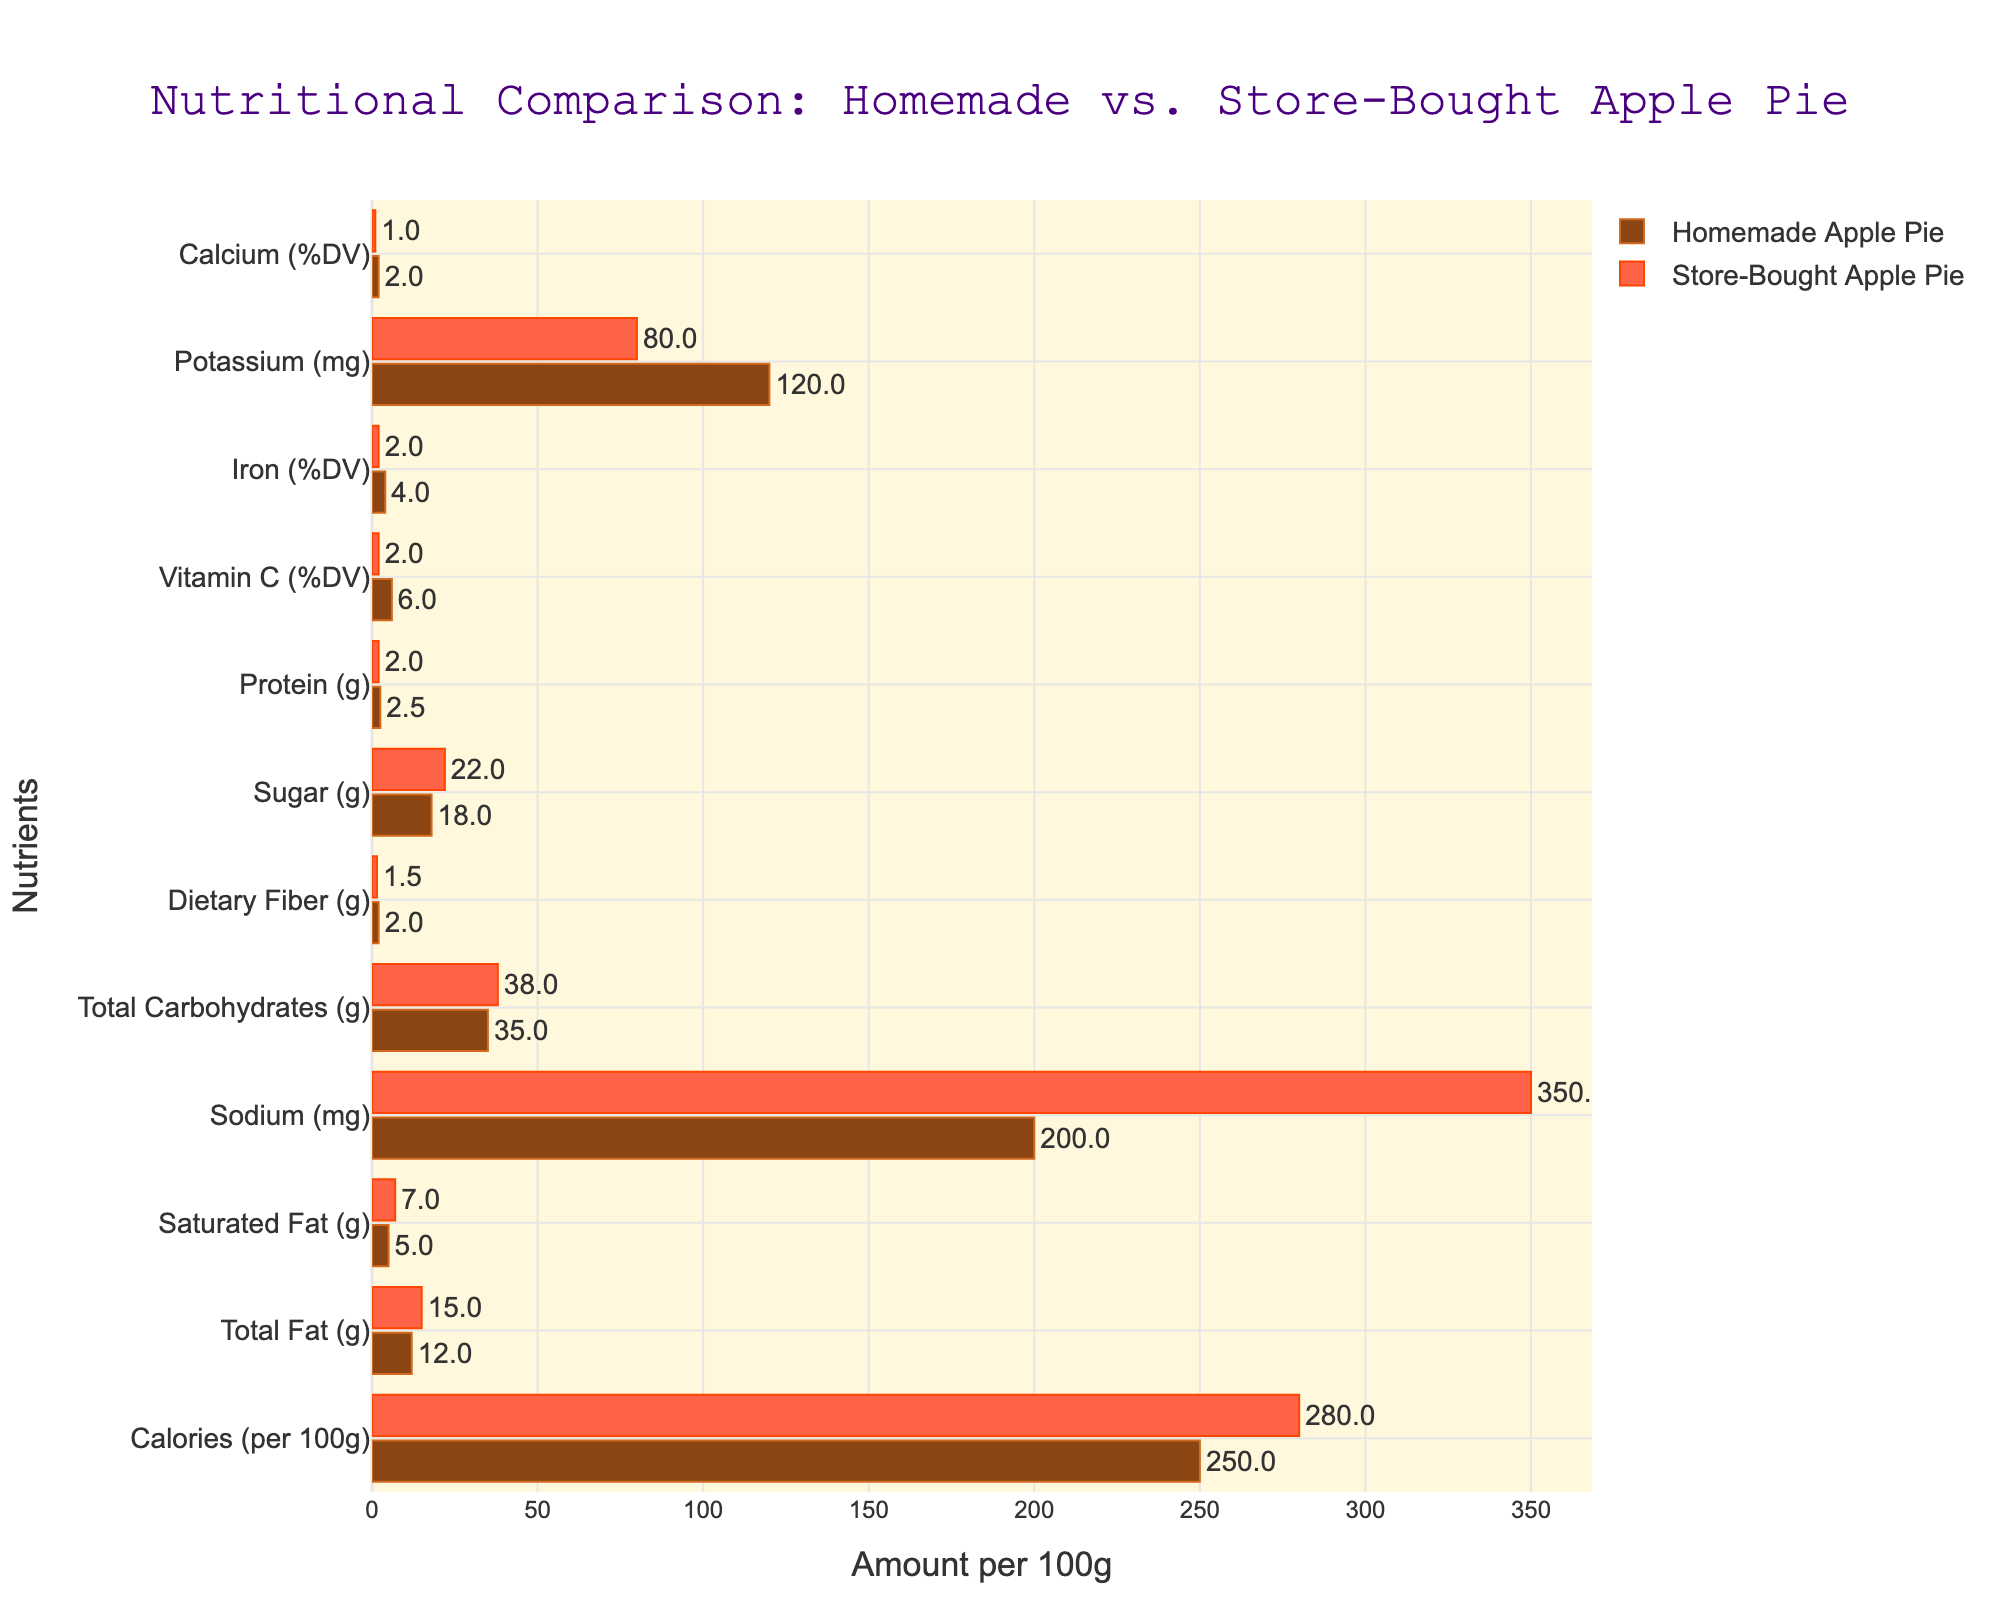What is the difference in calories per 100g between homemade and store-bought apple pies? The homemade apple pie has 250 calories per 100g, while the store-bought apple pie has 280 calories per 100g. The difference is 280 - 250.
Answer: 30 Which pie has a higher sodium content, and by how much? The homemade apple pie has 200mg of sodium per 100g, and the store-bought apple pie has 350mg of sodium per 100g. The difference is 350 - 200.
Answer: Store-bought, 150mg Which pie has more dietary fiber per 100g? The homemade apple pie has 2g of dietary fiber per 100g, while the store-bought apple pie has 1.5g of dietary fiber per 100g.
Answer: Homemade What is the combined amount of protein in both types of pies per 100g? The homemade apple pie has 2.5g of protein per 100g, and the store-bought apple pie has 2g of protein per 100g. The combined amount is 2.5 + 2.
Answer: 4.5g How much more sugar does the store-bought apple pie have compared to the homemade apple pie? The homemade apple pie has 18g of sugar per 100g, while the store-bought apple pie has 22g of sugar per 100g. The difference is 22 - 18.
Answer: 4g Which pie has a greater amount of total fat, and what is the difference? The homemade apple pie has 12g of total fat per 100g, and the store-bought apple pie has 15g of total fat per 100g. The difference is 15 - 12.
Answer: Store-bought, 3g Considering vitamin C (%DV), which pie is better, and by how much? The homemade apple pie provides 6% DV of vitamin C per 100g, while the store-bought apple pie provides 2% DV. The difference is 6 - 2.
Answer: Homemade, 4% DV If you eat 200g of store-bought apple pie, what is the total amount of sodium consumed? Store-bought apple pie contains 350mg of sodium per 100g. For 200g, the total sodium is 350mg * 2.
Answer: 700mg Between homemade apple pie and store-bought apple pie, which one offers more minerals, considering iron and calcium (%DV)? Homemade apple pie provides 4% DV of iron and 2% DV of calcium, totaling 6% DV. Store-bought apple pie provides 2% DV of iron and 1% DV of calcium, totaling 3% DV.
Answer: Homemade 